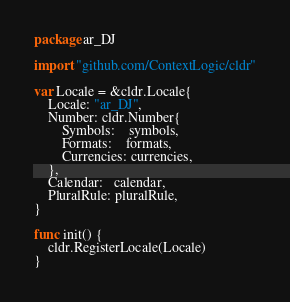<code> <loc_0><loc_0><loc_500><loc_500><_Go_>package ar_DJ

import "github.com/ContextLogic/cldr"

var Locale = &cldr.Locale{
	Locale: "ar_DJ",
	Number: cldr.Number{
		Symbols:    symbols,
		Formats:    formats,
		Currencies: currencies,
	},
	Calendar:   calendar,
	PluralRule: pluralRule,
}

func init() {
	cldr.RegisterLocale(Locale)
}
</code> 